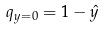<formula> <loc_0><loc_0><loc_500><loc_500>q _ { y = 0 } = 1 - \hat { y }</formula> 